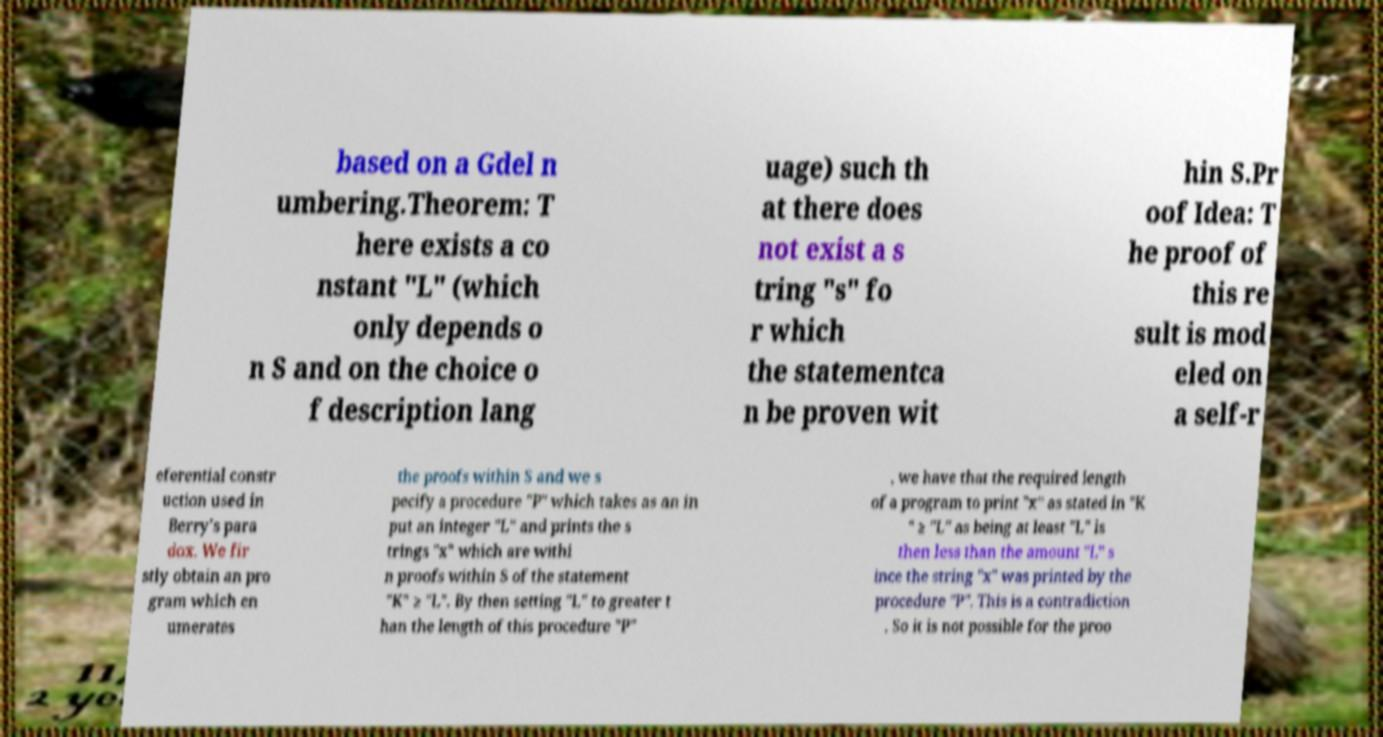Could you assist in decoding the text presented in this image and type it out clearly? based on a Gdel n umbering.Theorem: T here exists a co nstant "L" (which only depends o n S and on the choice o f description lang uage) such th at there does not exist a s tring "s" fo r which the statementca n be proven wit hin S.Pr oof Idea: T he proof of this re sult is mod eled on a self-r eferential constr uction used in Berry's para dox. We fir stly obtain an pro gram which en umerates the proofs within S and we s pecify a procedure "P" which takes as an in put an integer "L" and prints the s trings "x" which are withi n proofs within S of the statement "K" ≥ "L". By then setting "L" to greater t han the length of this procedure "P" , we have that the required length of a program to print "x" as stated in "K " ≥ "L" as being at least "L" is then less than the amount "L" s ince the string "x" was printed by the procedure "P". This is a contradiction . So it is not possible for the proo 